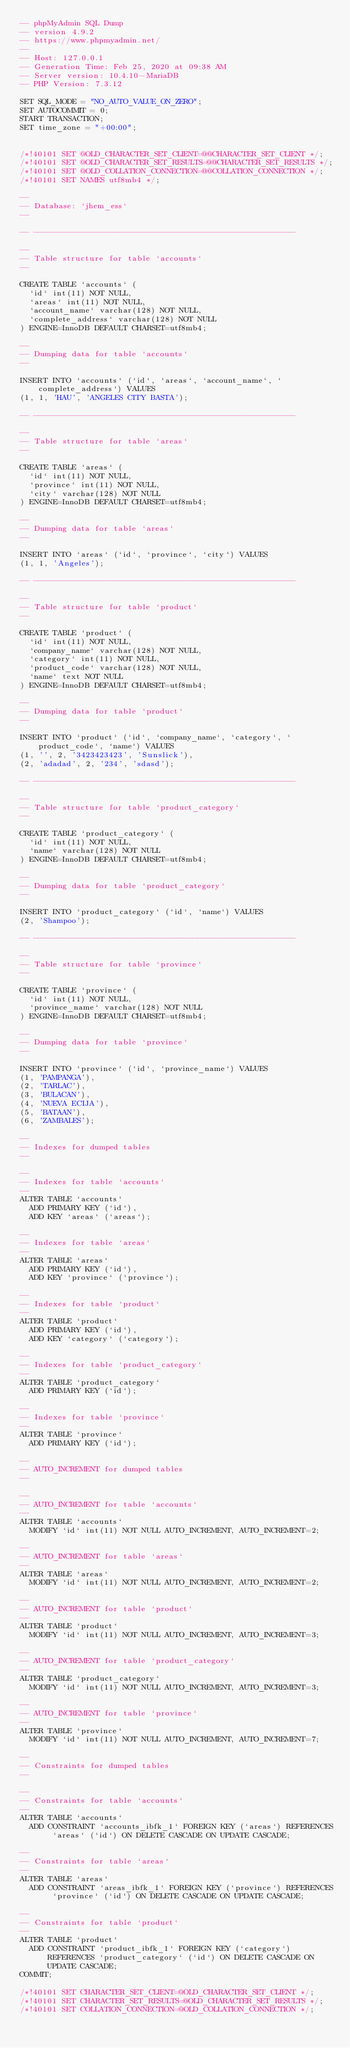Convert code to text. <code><loc_0><loc_0><loc_500><loc_500><_SQL_>-- phpMyAdmin SQL Dump
-- version 4.9.2
-- https://www.phpmyadmin.net/
--
-- Host: 127.0.0.1
-- Generation Time: Feb 25, 2020 at 09:38 AM
-- Server version: 10.4.10-MariaDB
-- PHP Version: 7.3.12

SET SQL_MODE = "NO_AUTO_VALUE_ON_ZERO";
SET AUTOCOMMIT = 0;
START TRANSACTION;
SET time_zone = "+00:00";


/*!40101 SET @OLD_CHARACTER_SET_CLIENT=@@CHARACTER_SET_CLIENT */;
/*!40101 SET @OLD_CHARACTER_SET_RESULTS=@@CHARACTER_SET_RESULTS */;
/*!40101 SET @OLD_COLLATION_CONNECTION=@@COLLATION_CONNECTION */;
/*!40101 SET NAMES utf8mb4 */;

--
-- Database: `jhem_ess`
--

-- --------------------------------------------------------

--
-- Table structure for table `accounts`
--

CREATE TABLE `accounts` (
  `id` int(11) NOT NULL,
  `areas` int(11) NOT NULL,
  `account_name` varchar(128) NOT NULL,
  `complete_address` varchar(128) NOT NULL
) ENGINE=InnoDB DEFAULT CHARSET=utf8mb4;

--
-- Dumping data for table `accounts`
--

INSERT INTO `accounts` (`id`, `areas`, `account_name`, `complete_address`) VALUES
(1, 1, 'HAU', 'ANGELES CITY BASTA');

-- --------------------------------------------------------

--
-- Table structure for table `areas`
--

CREATE TABLE `areas` (
  `id` int(11) NOT NULL,
  `province` int(11) NOT NULL,
  `city` varchar(128) NOT NULL
) ENGINE=InnoDB DEFAULT CHARSET=utf8mb4;

--
-- Dumping data for table `areas`
--

INSERT INTO `areas` (`id`, `province`, `city`) VALUES
(1, 1, 'Angeles');

-- --------------------------------------------------------

--
-- Table structure for table `product`
--

CREATE TABLE `product` (
  `id` int(11) NOT NULL,
  `company_name` varchar(128) NOT NULL,
  `category` int(11) NOT NULL,
  `product_code` varchar(128) NOT NULL,
  `name` text NOT NULL
) ENGINE=InnoDB DEFAULT CHARSET=utf8mb4;

--
-- Dumping data for table `product`
--

INSERT INTO `product` (`id`, `company_name`, `category`, `product_code`, `name`) VALUES
(1, '', 2, '3423423423', 'Sunslick'),
(2, 'adadad', 2, '234', 'sdasd');

-- --------------------------------------------------------

--
-- Table structure for table `product_category`
--

CREATE TABLE `product_category` (
  `id` int(11) NOT NULL,
  `name` varchar(128) NOT NULL
) ENGINE=InnoDB DEFAULT CHARSET=utf8mb4;

--
-- Dumping data for table `product_category`
--

INSERT INTO `product_category` (`id`, `name`) VALUES
(2, 'Shampoo');

-- --------------------------------------------------------

--
-- Table structure for table `province`
--

CREATE TABLE `province` (
  `id` int(11) NOT NULL,
  `province_name` varchar(128) NOT NULL
) ENGINE=InnoDB DEFAULT CHARSET=utf8mb4;

--
-- Dumping data for table `province`
--

INSERT INTO `province` (`id`, `province_name`) VALUES
(1, 'PAMPANGA'),
(2, 'TARLAC'),
(3, 'BULACAN'),
(4, 'NUEVA ECIJA'),
(5, 'BATAAN'),
(6, 'ZAMBALES');

--
-- Indexes for dumped tables
--

--
-- Indexes for table `accounts`
--
ALTER TABLE `accounts`
  ADD PRIMARY KEY (`id`),
  ADD KEY `areas` (`areas`);

--
-- Indexes for table `areas`
--
ALTER TABLE `areas`
  ADD PRIMARY KEY (`id`),
  ADD KEY `province` (`province`);

--
-- Indexes for table `product`
--
ALTER TABLE `product`
  ADD PRIMARY KEY (`id`),
  ADD KEY `category` (`category`);

--
-- Indexes for table `product_category`
--
ALTER TABLE `product_category`
  ADD PRIMARY KEY (`id`);

--
-- Indexes for table `province`
--
ALTER TABLE `province`
  ADD PRIMARY KEY (`id`);

--
-- AUTO_INCREMENT for dumped tables
--

--
-- AUTO_INCREMENT for table `accounts`
--
ALTER TABLE `accounts`
  MODIFY `id` int(11) NOT NULL AUTO_INCREMENT, AUTO_INCREMENT=2;

--
-- AUTO_INCREMENT for table `areas`
--
ALTER TABLE `areas`
  MODIFY `id` int(11) NOT NULL AUTO_INCREMENT, AUTO_INCREMENT=2;

--
-- AUTO_INCREMENT for table `product`
--
ALTER TABLE `product`
  MODIFY `id` int(11) NOT NULL AUTO_INCREMENT, AUTO_INCREMENT=3;

--
-- AUTO_INCREMENT for table `product_category`
--
ALTER TABLE `product_category`
  MODIFY `id` int(11) NOT NULL AUTO_INCREMENT, AUTO_INCREMENT=3;

--
-- AUTO_INCREMENT for table `province`
--
ALTER TABLE `province`
  MODIFY `id` int(11) NOT NULL AUTO_INCREMENT, AUTO_INCREMENT=7;

--
-- Constraints for dumped tables
--

--
-- Constraints for table `accounts`
--
ALTER TABLE `accounts`
  ADD CONSTRAINT `accounts_ibfk_1` FOREIGN KEY (`areas`) REFERENCES `areas` (`id`) ON DELETE CASCADE ON UPDATE CASCADE;

--
-- Constraints for table `areas`
--
ALTER TABLE `areas`
  ADD CONSTRAINT `areas_ibfk_1` FOREIGN KEY (`province`) REFERENCES `province` (`id`) ON DELETE CASCADE ON UPDATE CASCADE;

--
-- Constraints for table `product`
--
ALTER TABLE `product`
  ADD CONSTRAINT `product_ibfk_1` FOREIGN KEY (`category`) REFERENCES `product_category` (`id`) ON DELETE CASCADE ON UPDATE CASCADE;
COMMIT;

/*!40101 SET CHARACTER_SET_CLIENT=@OLD_CHARACTER_SET_CLIENT */;
/*!40101 SET CHARACTER_SET_RESULTS=@OLD_CHARACTER_SET_RESULTS */;
/*!40101 SET COLLATION_CONNECTION=@OLD_COLLATION_CONNECTION */;
</code> 